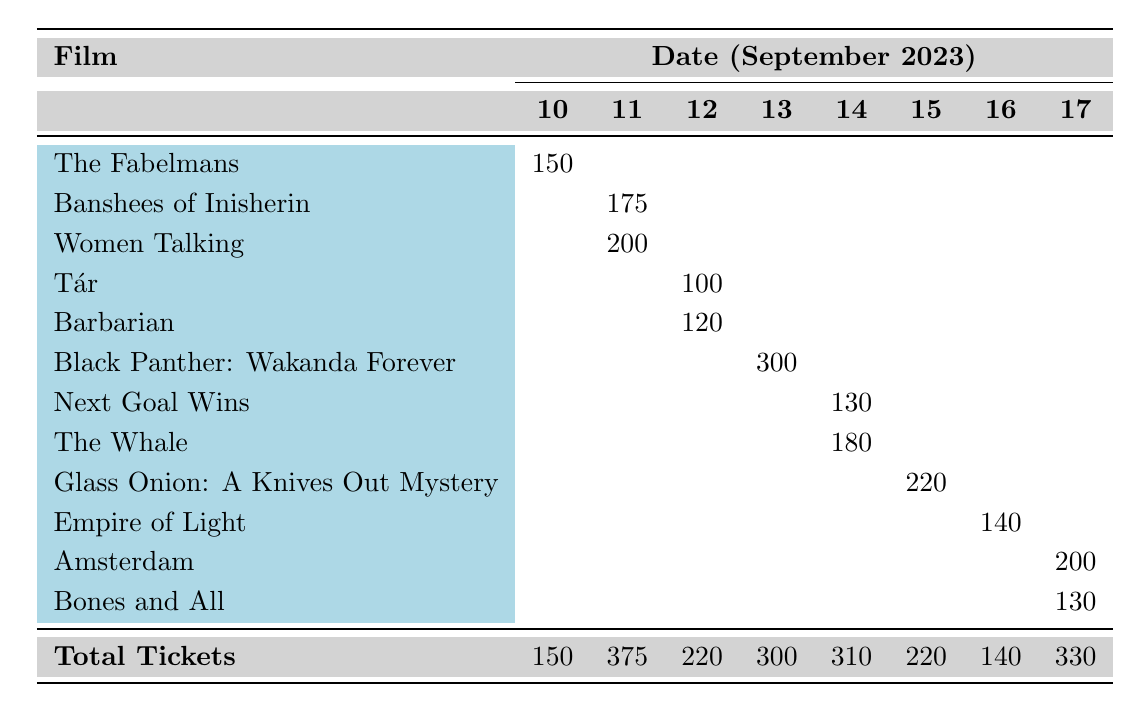What was the total number of tickets sold on September 12th? According to the table, on September 12th, Tár sold 100 tickets and Barbarian sold 120 tickets. Adding these two figures together gives 100 + 120 = 220 tickets sold in total on that date.
Answer: 220 Which film had the highest ticket sales, and how many tickets were sold? From the table, "Black Panther: Wakanda Forever" had the highest ticket sales with 300 tickets sold on September 13th.
Answer: Black Panther: Wakanda Forever; 300 Did "Amsterdam" sell more tickets than "Bones and All"? According to the table, "Amsterdam" sold 200 tickets, while "Bones and All" sold 130 tickets. Therefore, Amsterdam sold more tickets than Bones and All, making the statement true.
Answer: Yes What is the average number of tickets sold per day across the festival? To find the average, we first total the number of tickets sold each day: 150 (Sep 10) + 375 (Sep 11) + 220 (Sep 12) + 300 (Sep 13) + 310 (Sep 14) + 220 (Sep 15) + 140 (Sep 16) + 330 (Sep 17) = 1845. There are 8 days in total, so the average is 1845 / 8 = 230.625.
Answer: 230.625 On which date was "The Whale" shown, and how many tickets were sold? The table indicates that "The Whale" was shown on September 14th and had 180 tickets sold.
Answer: September 14th; 180 